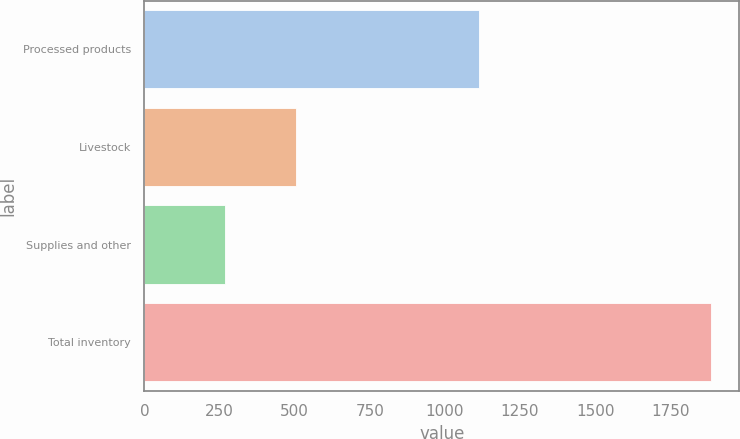Convert chart to OTSL. <chart><loc_0><loc_0><loc_500><loc_500><bar_chart><fcel>Processed products<fcel>Livestock<fcel>Supplies and other<fcel>Total inventory<nl><fcel>1112<fcel>505<fcel>268<fcel>1885<nl></chart> 